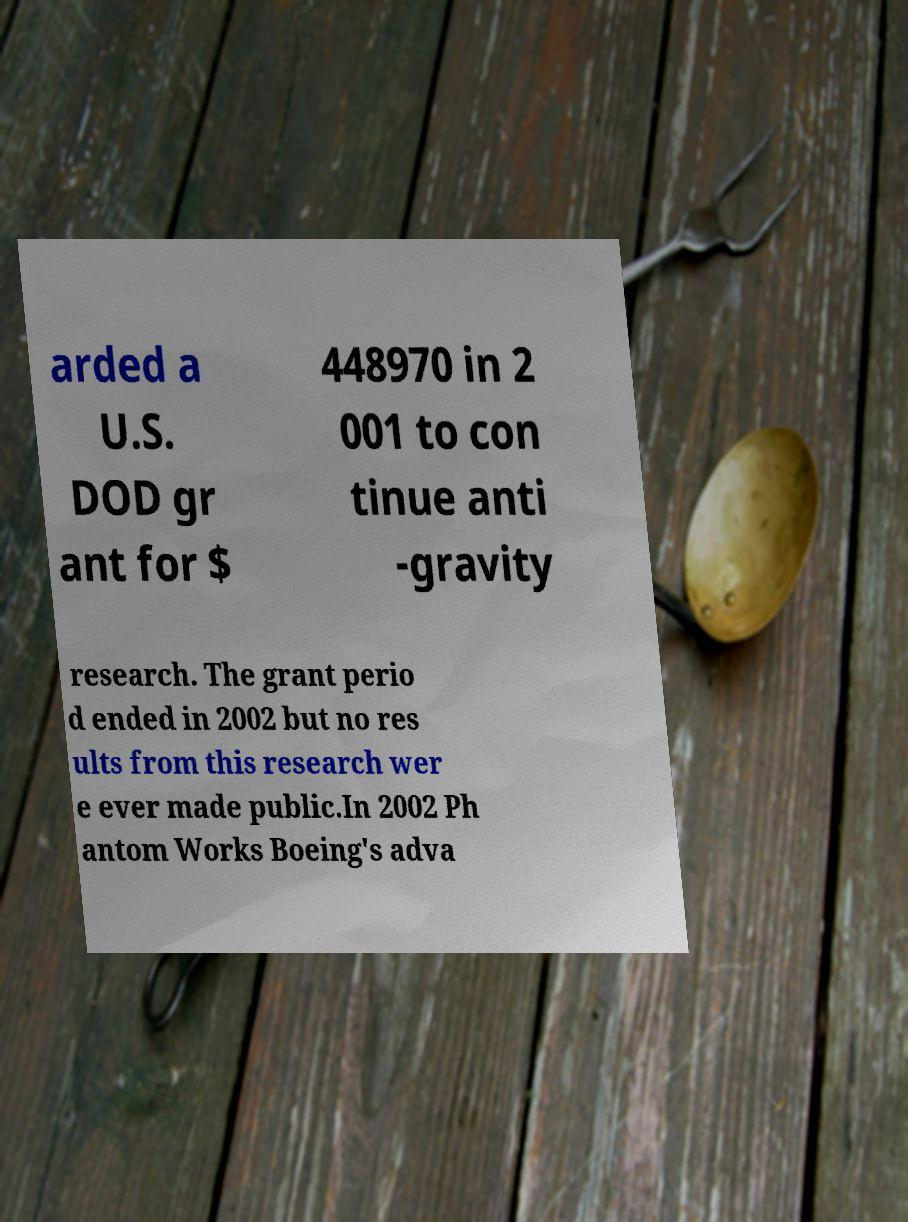Can you accurately transcribe the text from the provided image for me? arded a U.S. DOD gr ant for $ 448970 in 2 001 to con tinue anti -gravity research. The grant perio d ended in 2002 but no res ults from this research wer e ever made public.In 2002 Ph antom Works Boeing's adva 